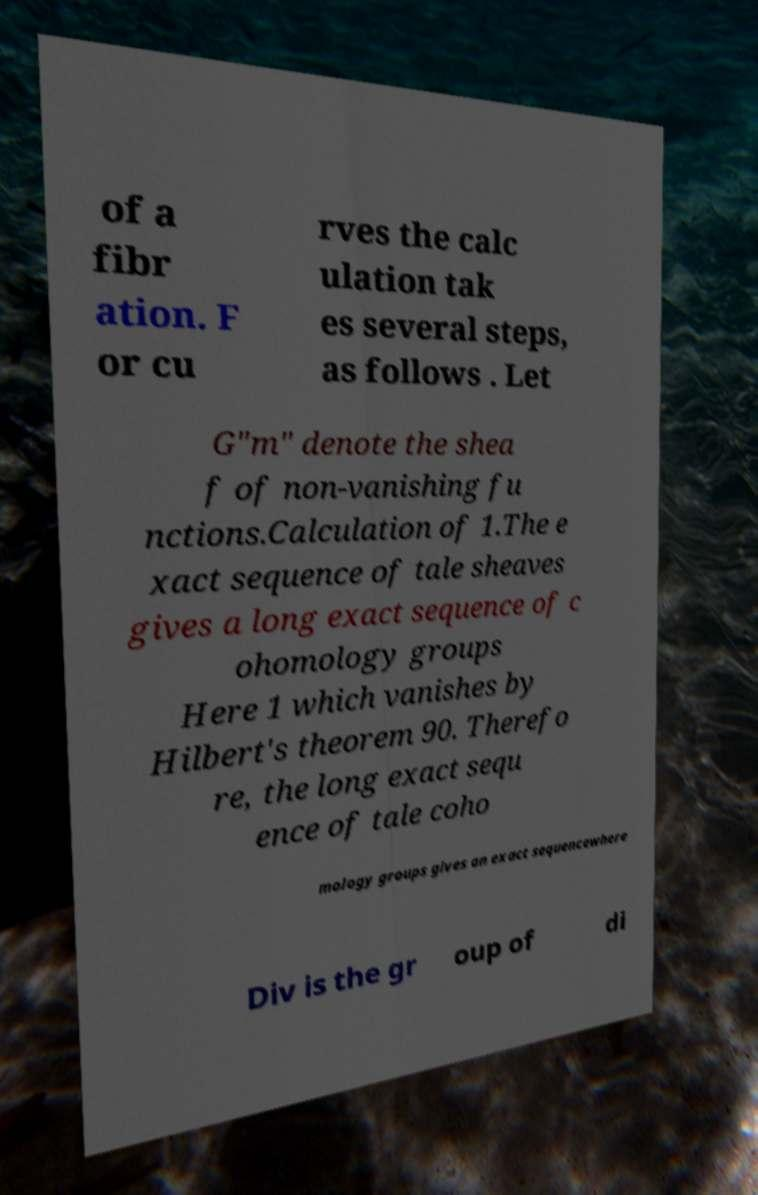There's text embedded in this image that I need extracted. Can you transcribe it verbatim? of a fibr ation. F or cu rves the calc ulation tak es several steps, as follows . Let G"m" denote the shea f of non-vanishing fu nctions.Calculation of 1.The e xact sequence of tale sheaves gives a long exact sequence of c ohomology groups Here 1 which vanishes by Hilbert's theorem 90. Therefo re, the long exact sequ ence of tale coho mology groups gives an exact sequencewhere Div is the gr oup of di 